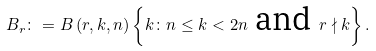Convert formula to latex. <formula><loc_0><loc_0><loc_500><loc_500>B _ { r } \colon = B \left ( r , k , n \right ) \left \{ k \colon n \leq k < 2 n \text { and } r \nmid k \right \} .</formula> 